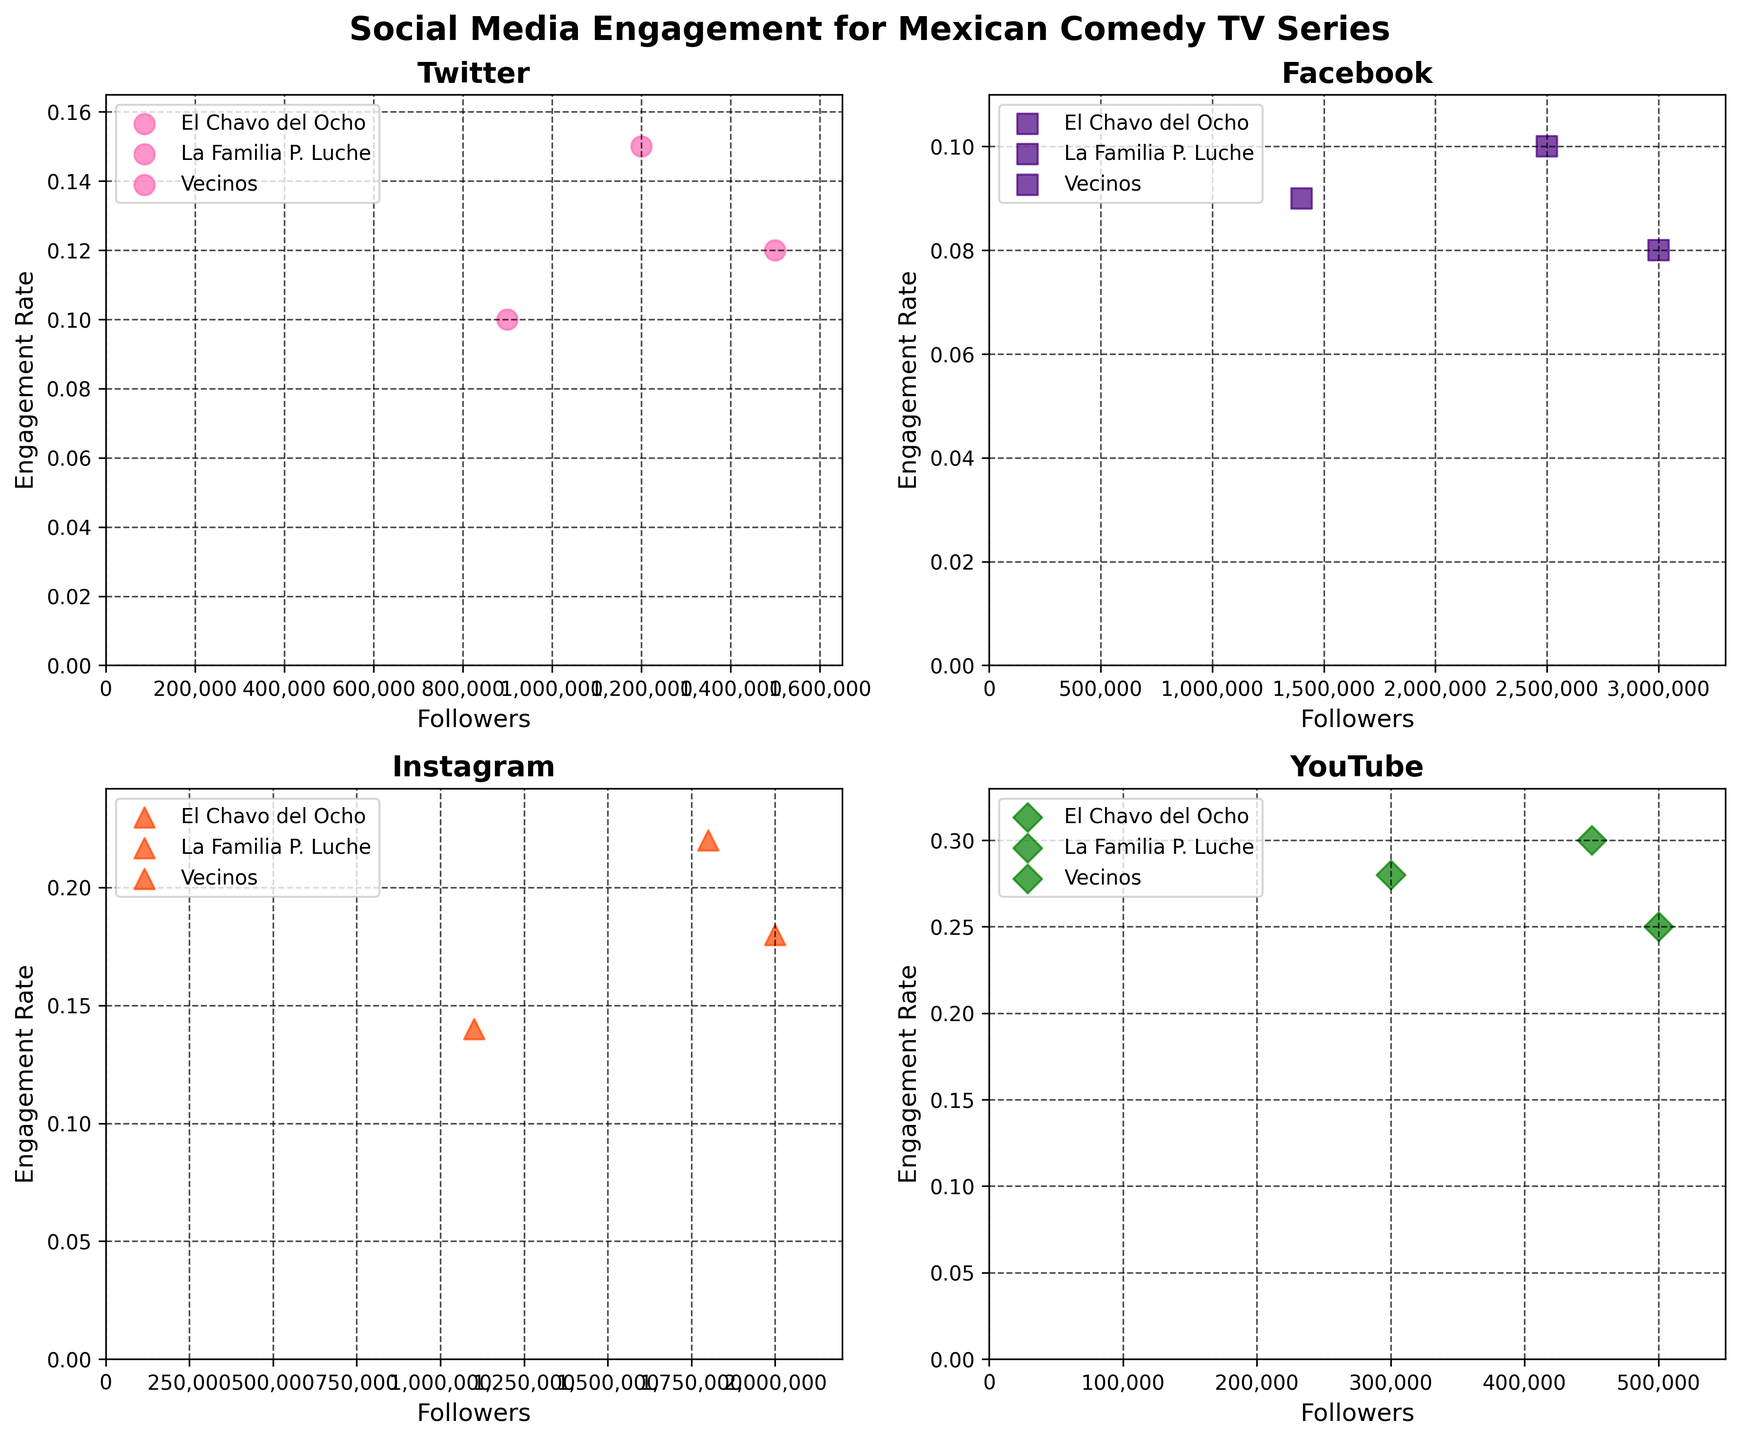Which social media platform has the highest engagement rate for "La Familia P. Luche"? Look at the subplot titles and find "La Familia P. Luche" in each. The highest engagement rate for "La Familia P. Luche" is on YouTube (0.30).
Answer: YouTube What is the total number of followers for "El Chavo del Ocho" across all platforms? Sum the followers of "El Chavo del Ocho" from each subplot: Twitter (1,500,000), Facebook (3,000,000), Instagram (2,000,000), and YouTube (500,000). The total is 1,500,000 + 3,000,000 + 2,000,000 + 500,000 = 7,000,000.
Answer: 7,000,000 Which series has a higher engagement rate on Instagram, "El Chavo del Ocho" or "Vecinos"? Compare the engagement rates of "El Chavo del Ocho" and "Vecinos" on the Instagram subplot. "El Chavo del Ocho" has 0.18, and "Vecinos" has 0.14. Thus, "El Chavo del Ocho" has a higher engagement rate.
Answer: El Chavo del Ocho How many data points are represented in the Twitter subplot? Count the number of unique series in the Twitter subplot: "El Chavo del Ocho", "La Familia P. Luche", "Vecinos". There are three data points.
Answer: 3 What's the average engagement rate on YouTube for all the series? Calculate the average of the engagement rates on YouTube: (0.25 + 0.30 + 0.28)/3. Sum = 0.83, and divide by 3. The average engagement rate is approximately 0.2767.
Answer: 0.2767 Which platform has the lowest engagement rate given the series data? Identify the lowest engagement rate in each subplot: Twitter (0.10 - "Vecinos"), Facebook (0.08 - "El Chavo del Ocho"), Instagram (0.14 - "Vecinos"), YouTube (0.25 - "El Chavo del Ocho"). The lowest engagement rate is 0.08 on Facebook.
Answer: Facebook On which platform does "El Chavo del Ocho" have the least followers? Look at the number of followers for "El Chavo del Ocho" in each subplot: Twitter (1,500,000), Facebook (3,000,000), Instagram (2,000,000), and YouTube (500,000). The least followers are on YouTube (500,000).
Answer: YouTube 